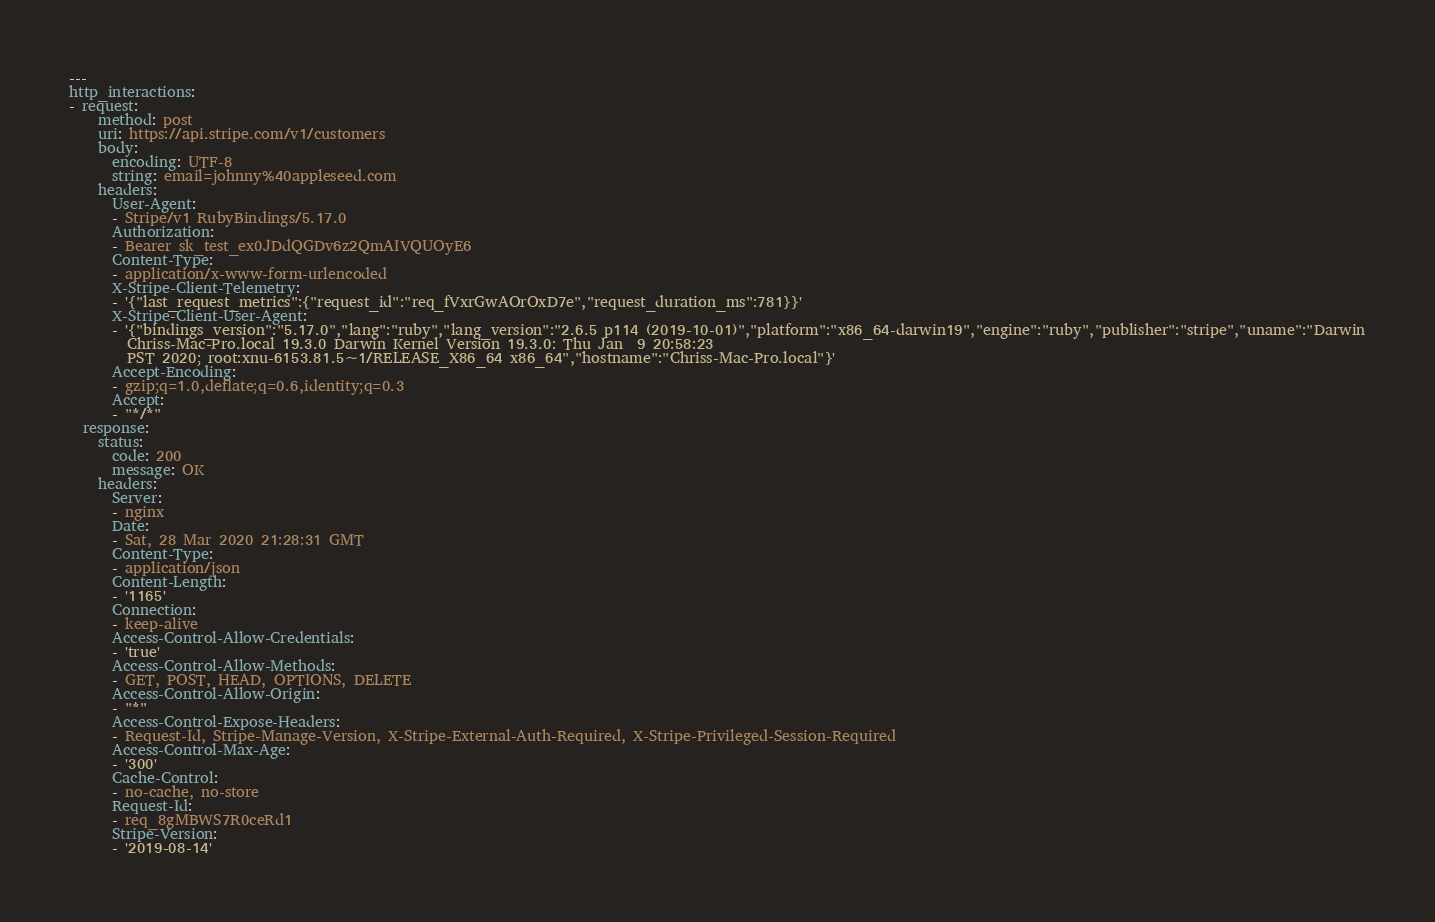<code> <loc_0><loc_0><loc_500><loc_500><_YAML_>---
http_interactions:
- request:
    method: post
    uri: https://api.stripe.com/v1/customers
    body:
      encoding: UTF-8
      string: email=johnny%40appleseed.com
    headers:
      User-Agent:
      - Stripe/v1 RubyBindings/5.17.0
      Authorization:
      - Bearer sk_test_ex0JDdQGDv6z2QmAIVQUOyE6
      Content-Type:
      - application/x-www-form-urlencoded
      X-Stripe-Client-Telemetry:
      - '{"last_request_metrics":{"request_id":"req_fVxrGwAOrOxD7e","request_duration_ms":781}}'
      X-Stripe-Client-User-Agent:
      - '{"bindings_version":"5.17.0","lang":"ruby","lang_version":"2.6.5 p114 (2019-10-01)","platform":"x86_64-darwin19","engine":"ruby","publisher":"stripe","uname":"Darwin
        Chriss-Mac-Pro.local 19.3.0 Darwin Kernel Version 19.3.0: Thu Jan  9 20:58:23
        PST 2020; root:xnu-6153.81.5~1/RELEASE_X86_64 x86_64","hostname":"Chriss-Mac-Pro.local"}'
      Accept-Encoding:
      - gzip;q=1.0,deflate;q=0.6,identity;q=0.3
      Accept:
      - "*/*"
  response:
    status:
      code: 200
      message: OK
    headers:
      Server:
      - nginx
      Date:
      - Sat, 28 Mar 2020 21:28:31 GMT
      Content-Type:
      - application/json
      Content-Length:
      - '1165'
      Connection:
      - keep-alive
      Access-Control-Allow-Credentials:
      - 'true'
      Access-Control-Allow-Methods:
      - GET, POST, HEAD, OPTIONS, DELETE
      Access-Control-Allow-Origin:
      - "*"
      Access-Control-Expose-Headers:
      - Request-Id, Stripe-Manage-Version, X-Stripe-External-Auth-Required, X-Stripe-Privileged-Session-Required
      Access-Control-Max-Age:
      - '300'
      Cache-Control:
      - no-cache, no-store
      Request-Id:
      - req_8gMBWS7R0ceRd1
      Stripe-Version:
      - '2019-08-14'</code> 